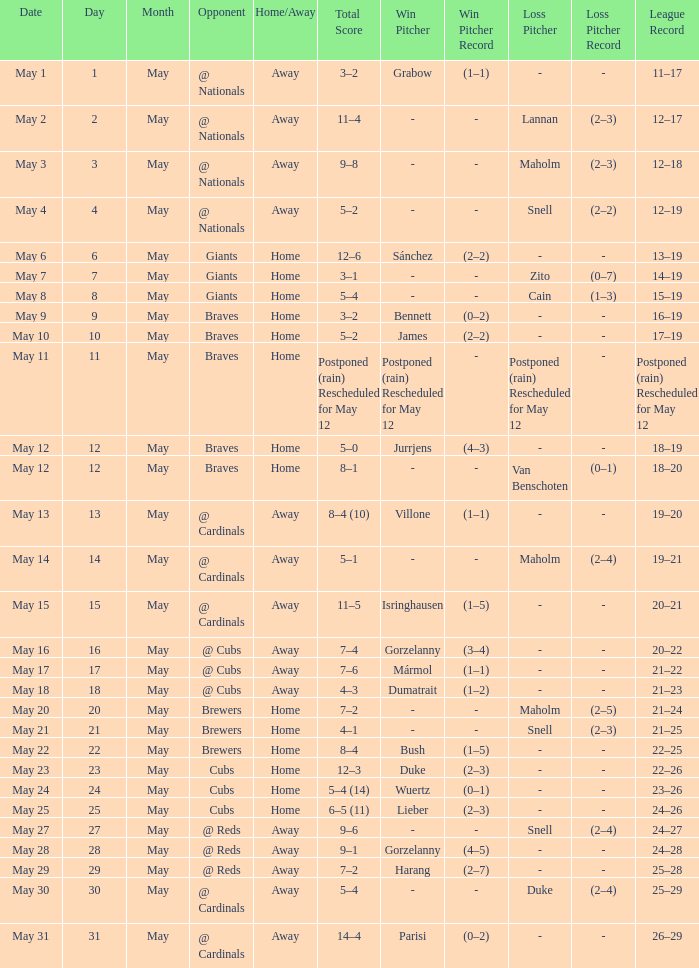Who was the opponent at the game with a score of 7–6? @ Cubs. 